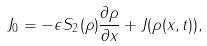<formula> <loc_0><loc_0><loc_500><loc_500>J _ { 0 } = - \epsilon S _ { 2 } ( \rho ) \frac { \partial \rho } { \partial x } + J ( \rho ( x , t ) ) ,</formula> 